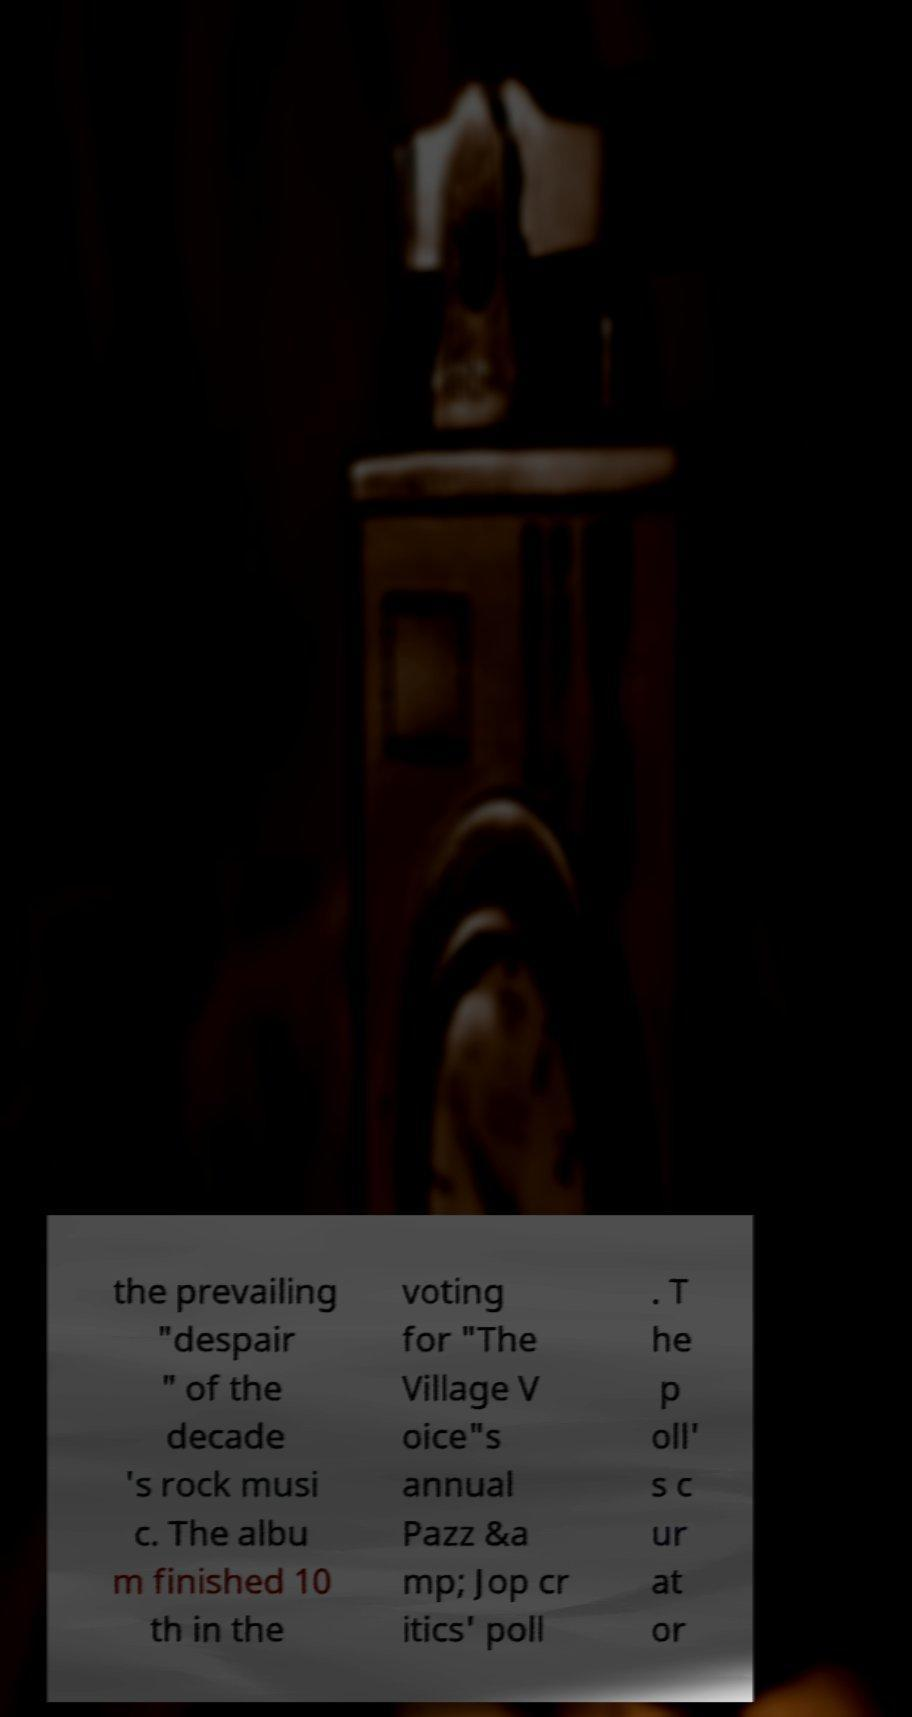Can you read and provide the text displayed in the image?This photo seems to have some interesting text. Can you extract and type it out for me? the prevailing "despair " of the decade 's rock musi c. The albu m finished 10 th in the voting for "The Village V oice"s annual Pazz &a mp; Jop cr itics' poll . T he p oll' s c ur at or 